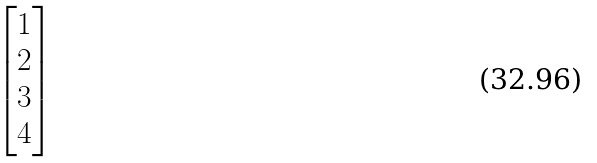Convert formula to latex. <formula><loc_0><loc_0><loc_500><loc_500>\begin{bmatrix} 1 \\ 2 \\ 3 \\ 4 \end{bmatrix}</formula> 